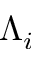<formula> <loc_0><loc_0><loc_500><loc_500>\Lambda _ { i }</formula> 